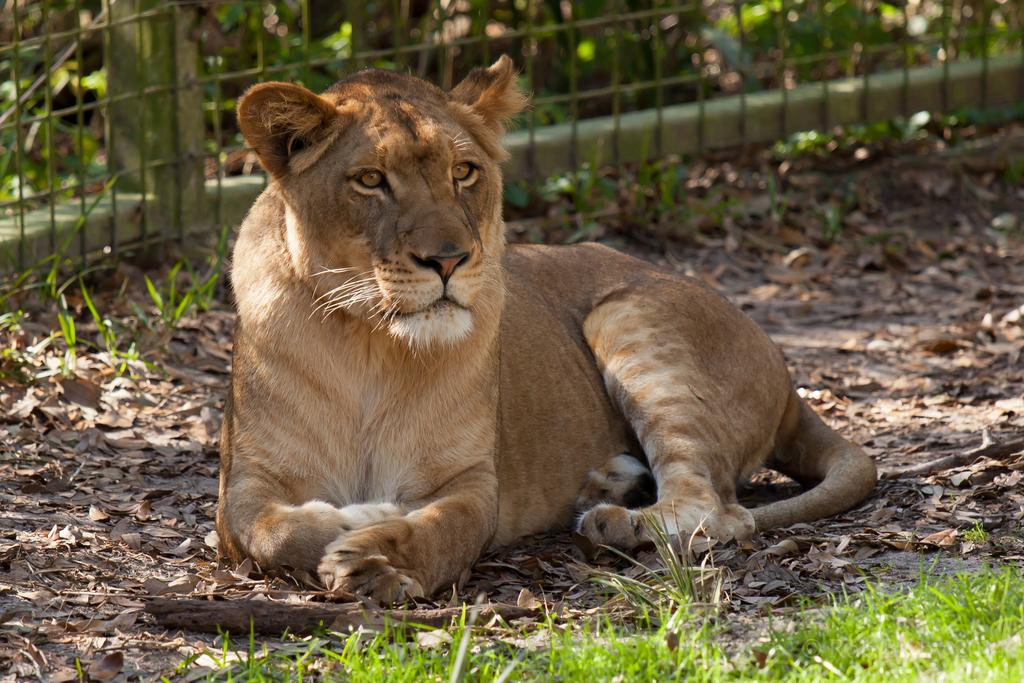What type of creature is present in the image? There is an animal in the image. Where is the animal located? The animal is sitting on the land. Can you describe the land in the image? The land has grass and dried leaves. What can be seen at the top of the image? There is a fence at the top of the image. What is visible in the background of the image? There are plants visible in the background. What type of hen can be seen carrying a pail in the image? There is no hen or pail present in the image. Is the horse in the image wearing a saddle? There is no horse present in the image. 